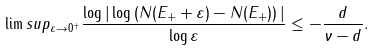<formula> <loc_0><loc_0><loc_500><loc_500>\lim s u p _ { \varepsilon \to 0 ^ { + } } \frac { \log | \log \left ( N ( E _ { + } + \varepsilon ) - N ( E _ { + } ) \right ) | } { \log \varepsilon } \leq - \frac { d } { \nu - d } .</formula> 